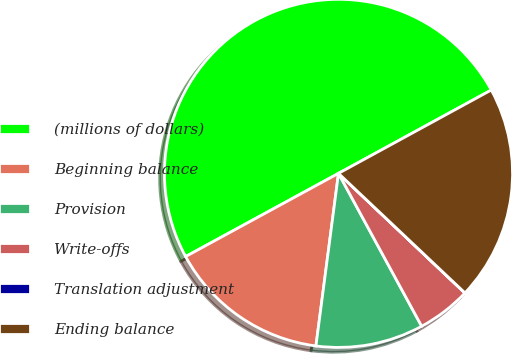Convert chart. <chart><loc_0><loc_0><loc_500><loc_500><pie_chart><fcel>(millions of dollars)<fcel>Beginning balance<fcel>Provision<fcel>Write-offs<fcel>Translation adjustment<fcel>Ending balance<nl><fcel>49.99%<fcel>15.0%<fcel>10.0%<fcel>5.01%<fcel>0.01%<fcel>20.0%<nl></chart> 